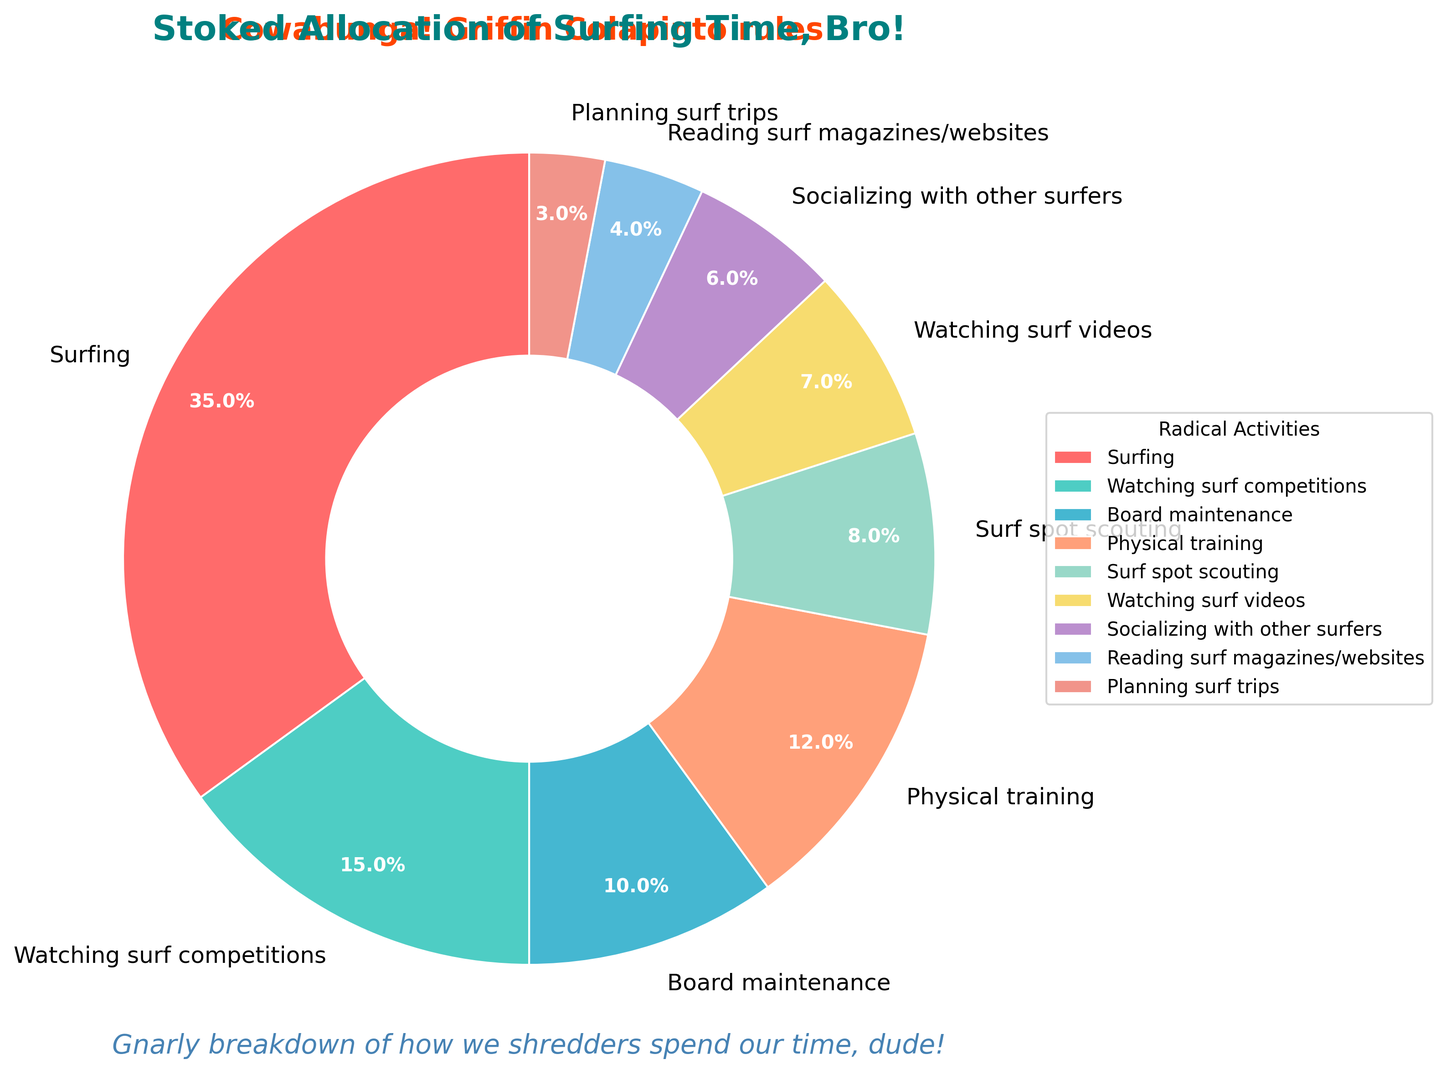Which category occupies the largest portion of the pie chart? The slice labeled "Surfing" is the largest one in the pie chart.
Answer: Surfing How much more time is spent on surfing compared to socializing with other surfers? Surfing occupies 35%, while socializing with other surfers occupies 6%. The difference is 35% - 6%.
Answer: 29% What activity has the smallest allocation of time, and what is its percentage? The smallest slice in the pie chart is for "Planning surf trips," which occupies 3%.
Answer: Planning surf trips, 3% Which activity's time allocation is closest to the combined percentage of watching surf competitions and watching surf videos? Watching surf competitions is 15% and watching surf videos is 7%, so their combined percentage is 15% + 7% = 22%. The activity with the closest percentage is physical training at 12%.
Answer: Physical training How does time spent on physical training compare to time spent on surf spot scouting? Physical training takes up 12%, while surf spot scouting takes 8%. Physical training is more.
Answer: More What is the total percentage of time spent on activities other than surfing? The total allocation is 100%, and surfing occupies 35%. So, other activities are 100% - 35%.
Answer: 65% Are there more activities that occupy less than 10% or more than 10% of the time? Activities less than 10% are: board maintenance (10%), surf spot scouting (8%), watching surf videos (7%), socializing with other surfers (6%), reading surf magazines/websites (4%), planning surf trips (3%). Activities more than 10% are: surfing (35%), watching surf competitions (15%), physical training (12%).
Answer: Less than 10% Do socializing with other surfers and reading surf magazines/websites combined allocate more time than board maintenance? Socializing with other surfers is 6% and reading surf magazines/websites is 4%. Combined, they total 6% + 4% = 10%, which is equal to board maintenance's 10%.
Answer: Equal What is the median percentage of time allocated among the activities? List: 3%, 4%, 6%, 7%, 8%, 10%, 12%, 15%, 35%. The median is the middle value, which is 8%.
Answer: 8% If we exclude surfing, what is the mean percentage of time spent on the remaining activities? Excluding surfing, the percentages are 15%, 10%, 12%, 8%, 7%, 6%, 4%, and 3%. The sum of these values is 65%. There are 8 activities, so the mean is 65%/8.
Answer: 8.125% 